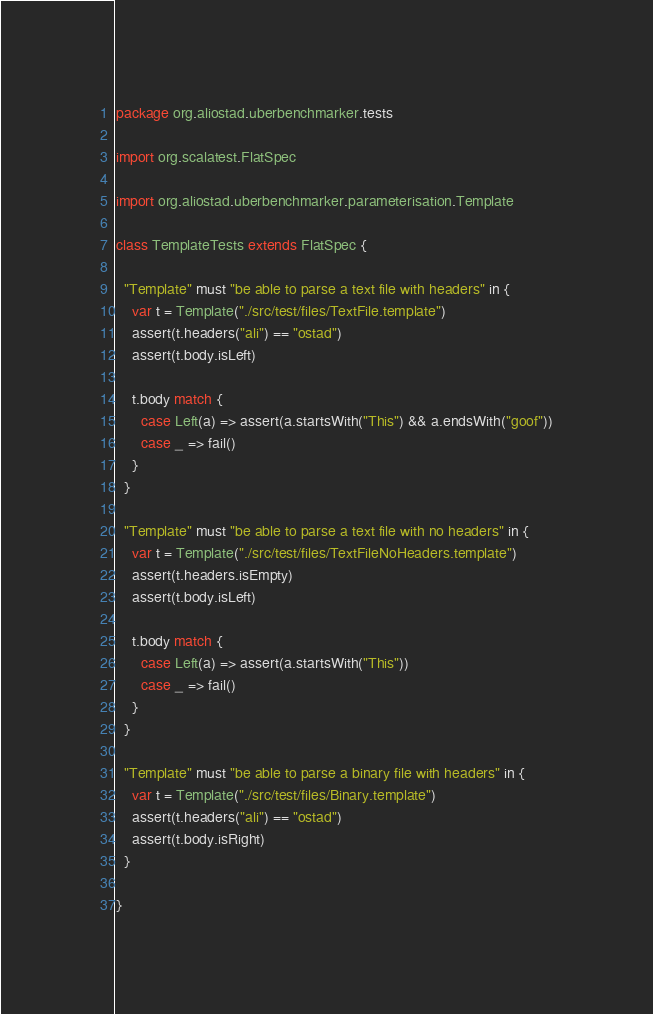Convert code to text. <code><loc_0><loc_0><loc_500><loc_500><_Scala_>package org.aliostad.uberbenchmarker.tests

import org.scalatest.FlatSpec

import org.aliostad.uberbenchmarker.parameterisation.Template

class TemplateTests extends FlatSpec {

  "Template" must "be able to parse a text file with headers" in {
    var t = Template("./src/test/files/TextFile.template")
    assert(t.headers("ali") == "ostad")
    assert(t.body.isLeft)

    t.body match {
      case Left(a) => assert(a.startsWith("This") && a.endsWith("goof"))
      case _ => fail()
    }
  }

  "Template" must "be able to parse a text file with no headers" in {
    var t = Template("./src/test/files/TextFileNoHeaders.template")
    assert(t.headers.isEmpty)
    assert(t.body.isLeft)

    t.body match {
      case Left(a) => assert(a.startsWith("This"))
      case _ => fail()
    }
  }

  "Template" must "be able to parse a binary file with headers" in {
    var t = Template("./src/test/files/Binary.template")
    assert(t.headers("ali") == "ostad")
    assert(t.body.isRight)
  }

}
</code> 